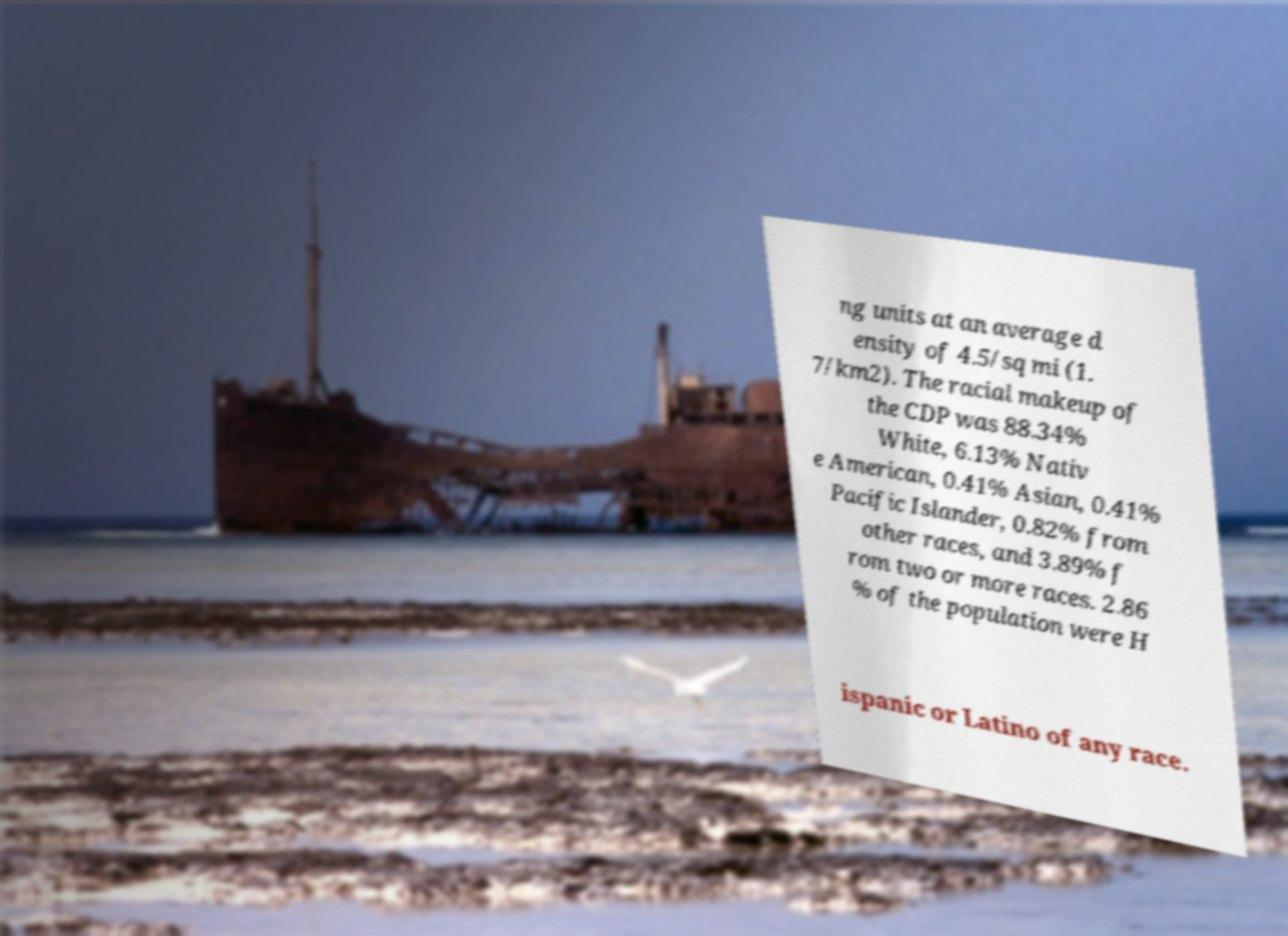For documentation purposes, I need the text within this image transcribed. Could you provide that? ng units at an average d ensity of 4.5/sq mi (1. 7/km2). The racial makeup of the CDP was 88.34% White, 6.13% Nativ e American, 0.41% Asian, 0.41% Pacific Islander, 0.82% from other races, and 3.89% f rom two or more races. 2.86 % of the population were H ispanic or Latino of any race. 